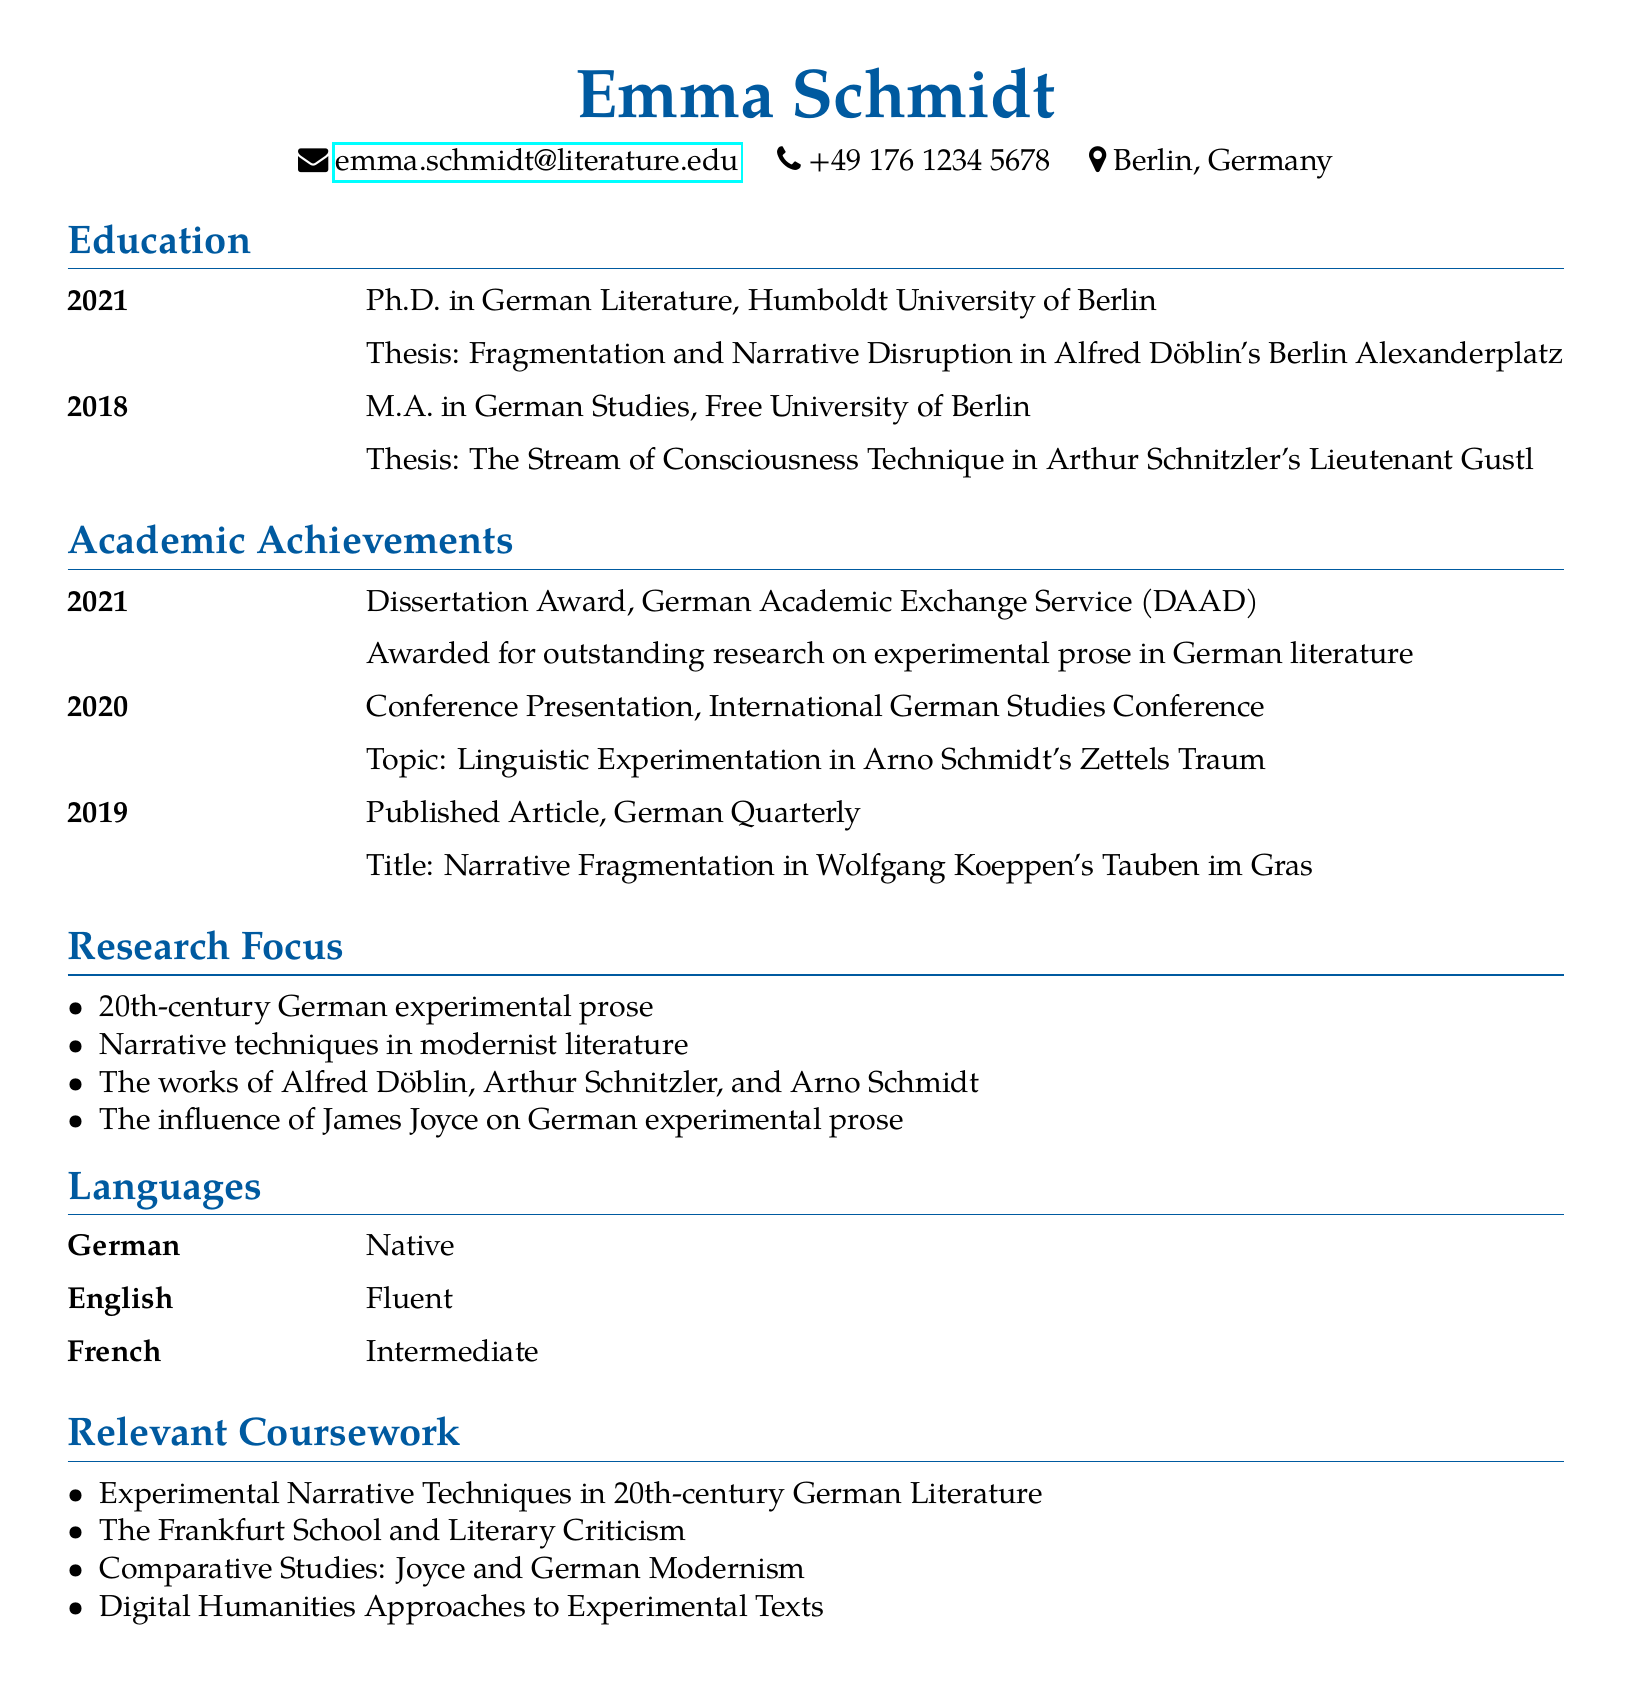what is the name of the candidate? The name of the candidate is stated at the top of the document.
Answer: Emma Schmidt which degree was awarded in 2021? The degree awarded in 2021 can be found in the education section.
Answer: Ph.D. in German Literature what was the thesis topic for the M.A. degree? The thesis topic for the M.A. degree is mentioned in the education section.
Answer: The Stream of Consciousness Technique in Arthur Schnitzler's Lieutenant Gustl who awarded the Dissertation Award? The organization that awarded the Dissertation Award is specified in the academic achievements section.
Answer: German Academic Exchange Service (DAAD) in what year was the article published in the German Quarterly? The publishing year of the article in the German Quarterly is indicated in the academic achievements section.
Answer: 2019 what topic did Emma present at the International German Studies Conference? The presentation topic is listed under academic achievements.
Answer: Linguistic Experimentation in Arno Schmidt's Zettels Traum which author is associated with the thesis on fragmentation? The author linked to the thesis on fragmentation is mentioned in the education section.
Answer: Alfred Döblin what is one of the research focuses mentioned in the document? The research focus can be found in the research focus section of the document.
Answer: 20th-century German experimental prose how many languages is Emma proficient in? The number of languages proficient by Emma is indicated in the languages section.
Answer: 3 what course addresses Digital Humanities Approaches? The relevant coursework section lists the courses, including one about Digital Humanities.
Answer: Digital Humanities Approaches to Experimental Texts 